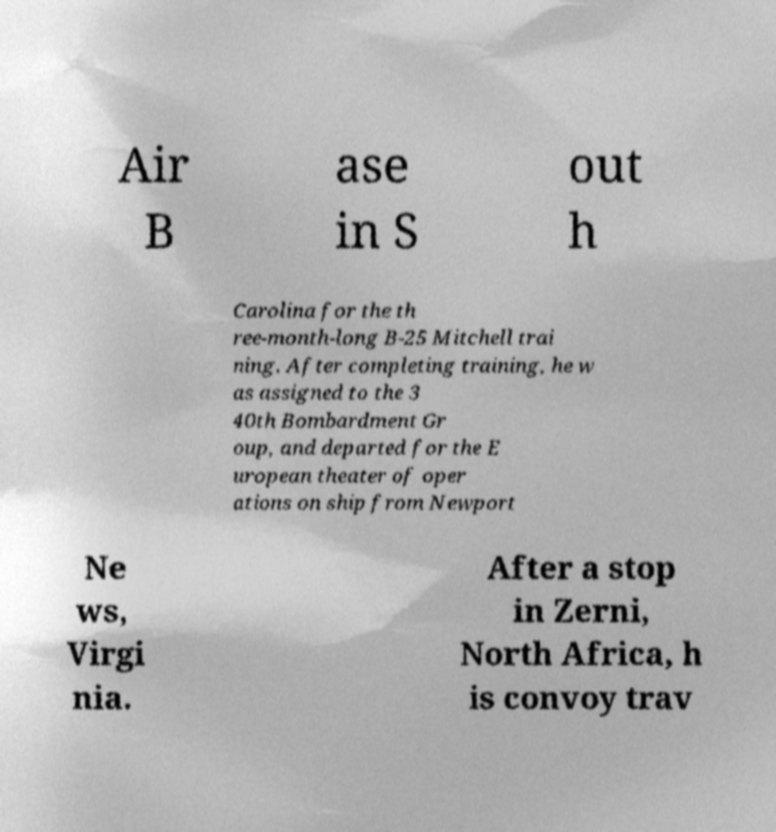I need the written content from this picture converted into text. Can you do that? Air B ase in S out h Carolina for the th ree-month-long B-25 Mitchell trai ning. After completing training, he w as assigned to the 3 40th Bombardment Gr oup, and departed for the E uropean theater of oper ations on ship from Newport Ne ws, Virgi nia. After a stop in Zerni, North Africa, h is convoy trav 